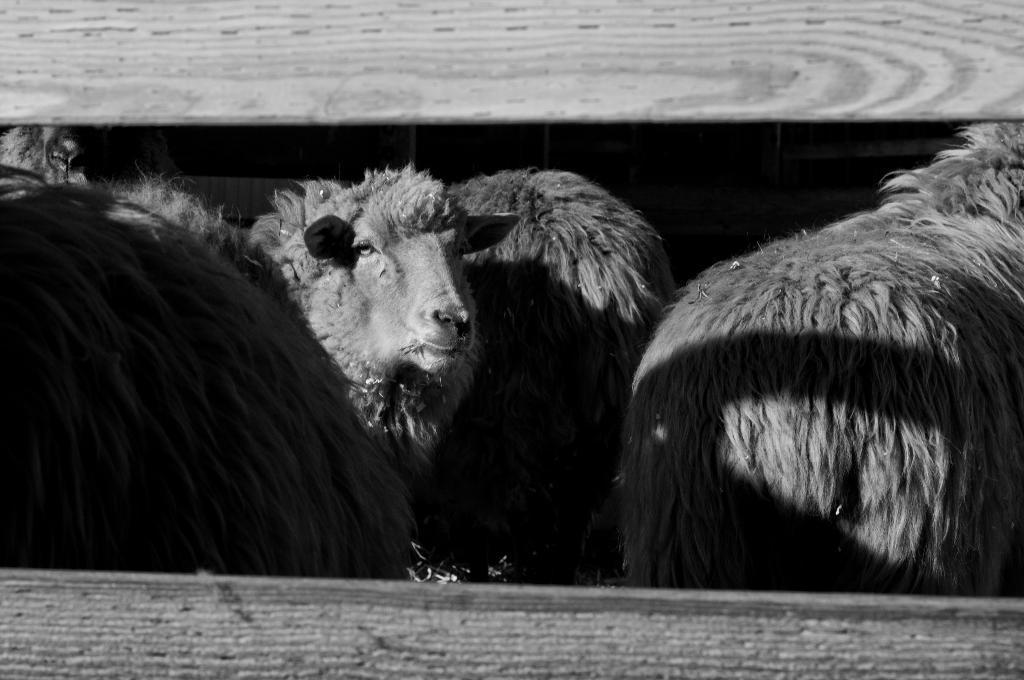Could you give a brief overview of what you see in this image? This is a black and white picture. In this picture, we see the sheep. One of the sheep is looking at the camera. In front of the picture, it might be a wooden fence. 